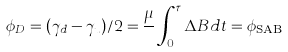Convert formula to latex. <formula><loc_0><loc_0><loc_500><loc_500>\phi _ { D } = ( \gamma _ { d } - \gamma _ { u } ) / 2 = \frac { \mu } { } \int _ { 0 } ^ { \tau } \Delta B d t = \phi _ { { \text {SAB} } }</formula> 